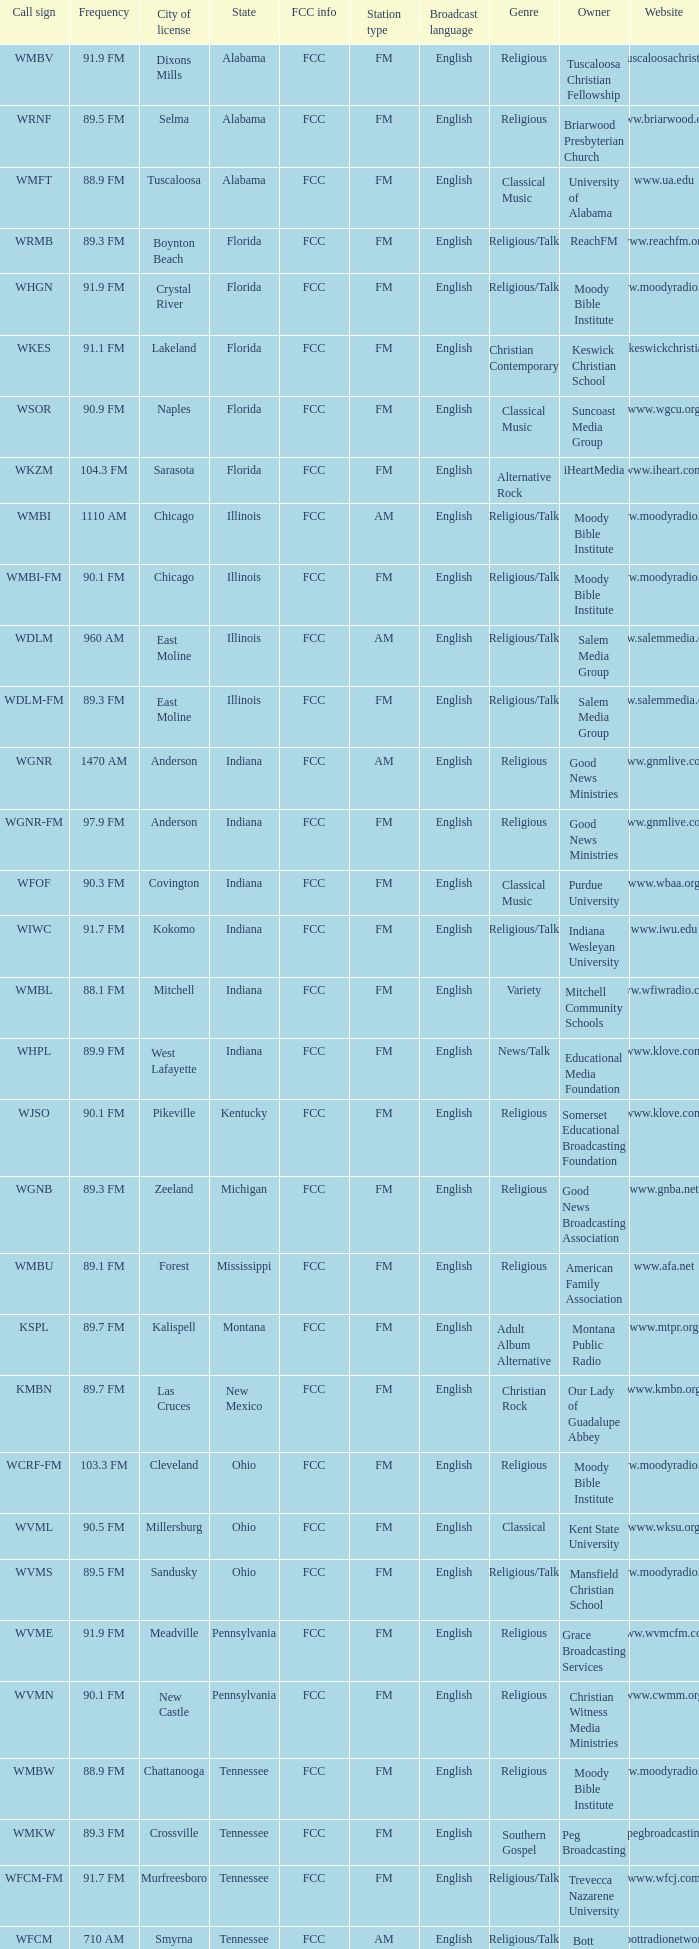Write the full table. {'header': ['Call sign', 'Frequency', 'City of license', 'State', 'FCC info', 'Station type', 'Broadcast language', 'Genre', 'Owner', 'Website'], 'rows': [['WMBV', '91.9 FM', 'Dixons Mills', 'Alabama', 'FCC', 'FM', 'English', 'Religious', 'Tuscaloosa Christian Fellowship', 'www.tuscaloosachristian.org'], ['WRNF', '89.5 FM', 'Selma', 'Alabama', 'FCC', 'FM', 'English', 'Religious', 'Briarwood Presbyterian Church', 'www.briarwood.org'], ['WMFT', '88.9 FM', 'Tuscaloosa', 'Alabama', 'FCC', 'FM', 'English', 'Classical Music', 'University of Alabama', 'www.ua.edu'], ['WRMB', '89.3 FM', 'Boynton Beach', 'Florida', 'FCC', 'FM', 'English', 'Religious/Talk', 'ReachFM', 'www.reachfm.org'], ['WHGN', '91.9 FM', 'Crystal River', 'Florida', 'FCC', 'FM', 'English', 'Religious/Talk', 'Moody Bible Institute', 'www.moodyradio.org'], ['WKES', '91.1 FM', 'Lakeland', 'Florida', 'FCC', 'FM', 'English', 'Christian Contemporary', 'Keswick Christian School', 'www.keswickchristian.org'], ['WSOR', '90.9 FM', 'Naples', 'Florida', 'FCC', 'FM', 'English', 'Classical Music', 'Suncoast Media Group', 'www.wgcu.org'], ['WKZM', '104.3 FM', 'Sarasota', 'Florida', 'FCC', 'FM', 'English', 'Alternative Rock', 'iHeartMedia', 'www.iheart.com'], ['WMBI', '1110 AM', 'Chicago', 'Illinois', 'FCC', 'AM', 'English', 'Religious/Talk', 'Moody Bible Institute', 'www.moodyradio.org'], ['WMBI-FM', '90.1 FM', 'Chicago', 'Illinois', 'FCC', 'FM', 'English', 'Religious/Talk', 'Moody Bible Institute', 'www.moodyradio.org'], ['WDLM', '960 AM', 'East Moline', 'Illinois', 'FCC', 'AM', 'English', 'Religious/Talk', 'Salem Media Group', 'www.salemmedia.com'], ['WDLM-FM', '89.3 FM', 'East Moline', 'Illinois', 'FCC', 'FM', 'English', 'Religious/Talk', 'Salem Media Group', 'www.salemmedia.com'], ['WGNR', '1470 AM', 'Anderson', 'Indiana', 'FCC', 'AM', 'English', 'Religious', 'Good News Ministries', 'www.gnmlive.com'], ['WGNR-FM', '97.9 FM', 'Anderson', 'Indiana', 'FCC', 'FM', 'English', 'Religious', 'Good News Ministries', 'www.gnmlive.com'], ['WFOF', '90.3 FM', 'Covington', 'Indiana', 'FCC', 'FM', 'English', 'Classical Music', 'Purdue University', 'www.wbaa.org'], ['WIWC', '91.7 FM', 'Kokomo', 'Indiana', 'FCC', 'FM', 'English', 'Religious/Talk', 'Indiana Wesleyan University', 'www.iwu.edu'], ['WMBL', '88.1 FM', 'Mitchell', 'Indiana', 'FCC', 'FM', 'English', 'Variety', 'Mitchell Community Schools', 'www.wfiwradio.com'], ['WHPL', '89.9 FM', 'West Lafayette', 'Indiana', 'FCC', 'FM', 'English', 'News/Talk', 'Educational Media Foundation', 'www.klove.com'], ['WJSO', '90.1 FM', 'Pikeville', 'Kentucky', 'FCC', 'FM', 'English', 'Religious', 'Somerset Educational Broadcasting Foundation', 'www.klove.com'], ['WGNB', '89.3 FM', 'Zeeland', 'Michigan', 'FCC', 'FM', 'English', 'Religious', 'Good News Broadcasting Association', 'www.gnba.net'], ['WMBU', '89.1 FM', 'Forest', 'Mississippi', 'FCC', 'FM', 'English', 'Religious', 'American Family Association', 'www.afa.net'], ['KSPL', '89.7 FM', 'Kalispell', 'Montana', 'FCC', 'FM', 'English', 'Adult Album Alternative', 'Montana Public Radio', 'www.mtpr.org'], ['KMBN', '89.7 FM', 'Las Cruces', 'New Mexico', 'FCC', 'FM', 'English', 'Christian Rock', 'Our Lady of Guadalupe Abbey', 'www.kmbn.org'], ['WCRF-FM', '103.3 FM', 'Cleveland', 'Ohio', 'FCC', 'FM', 'English', 'Religious', 'Moody Bible Institute', 'www.moodyradio.org'], ['WVML', '90.5 FM', 'Millersburg', 'Ohio', 'FCC', 'FM', 'English', 'Classical', 'Kent State University', 'www.wksu.org'], ['WVMS', '89.5 FM', 'Sandusky', 'Ohio', 'FCC', 'FM', 'English', 'Religious/Talk', 'Mansfield Christian School', 'www.moodyradio.org'], ['WVME', '91.9 FM', 'Meadville', 'Pennsylvania', 'FCC', 'FM', 'English', 'Religious', 'Grace Broadcasting Services', 'www.wvmcfm.com'], ['WVMN', '90.1 FM', 'New Castle', 'Pennsylvania', 'FCC', 'FM', 'English', 'Religious', 'Christian Witness Media Ministries', 'www.cwmm.org'], ['WMBW', '88.9 FM', 'Chattanooga', 'Tennessee', 'FCC', 'FM', 'English', 'Religious', 'Moody Bible Institute', 'www.moodyradio.org'], ['WMKW', '89.3 FM', 'Crossville', 'Tennessee', 'FCC', 'FM', 'English', 'Southern Gospel', 'Peg Broadcasting', 'www.pegbroadcasting.com'], ['WFCM-FM', '91.7 FM', 'Murfreesboro', 'Tennessee', 'FCC', 'FM', 'English', 'Religious/Talk', 'Trevecca Nazarene University', 'www.wfcj.com'], ['WFCM', '710 AM', 'Smyrna', 'Tennessee', 'FCC', 'AM', 'English', 'Religious/Talk', 'Bott Radio Network', 'www.bottradionetwork.com'], ['KMLW', '88.3 FM', 'Moses Lake', 'Washington', 'FCC', 'FM', 'English', 'Talk', 'Northwest Public Broadcasting', 'www.nwpb.org'], ['KMBI', '1330 AM', 'Spokane', 'Washington', 'FCC', 'AM', 'English', 'Religious', 'University of Northwestern-St. Paul', 'www.faithradio.org'], ['KMBI-FM', '107.9 FM', 'Spokane', 'Washington', 'FCC', 'FM', 'English', 'Religious', 'University of Northwestern-St. Paul', 'www.faithradio.org'], ['KMWY', '91.1 FM', 'Jackson', 'Wyoming', 'FCC', 'FM', 'English', 'Public', 'Wyoming Public Media', 'www.wyomingpublicmedia.org']]} What is the frequency of the radio station with a call sign of WGNR-FM? 97.9 FM. 